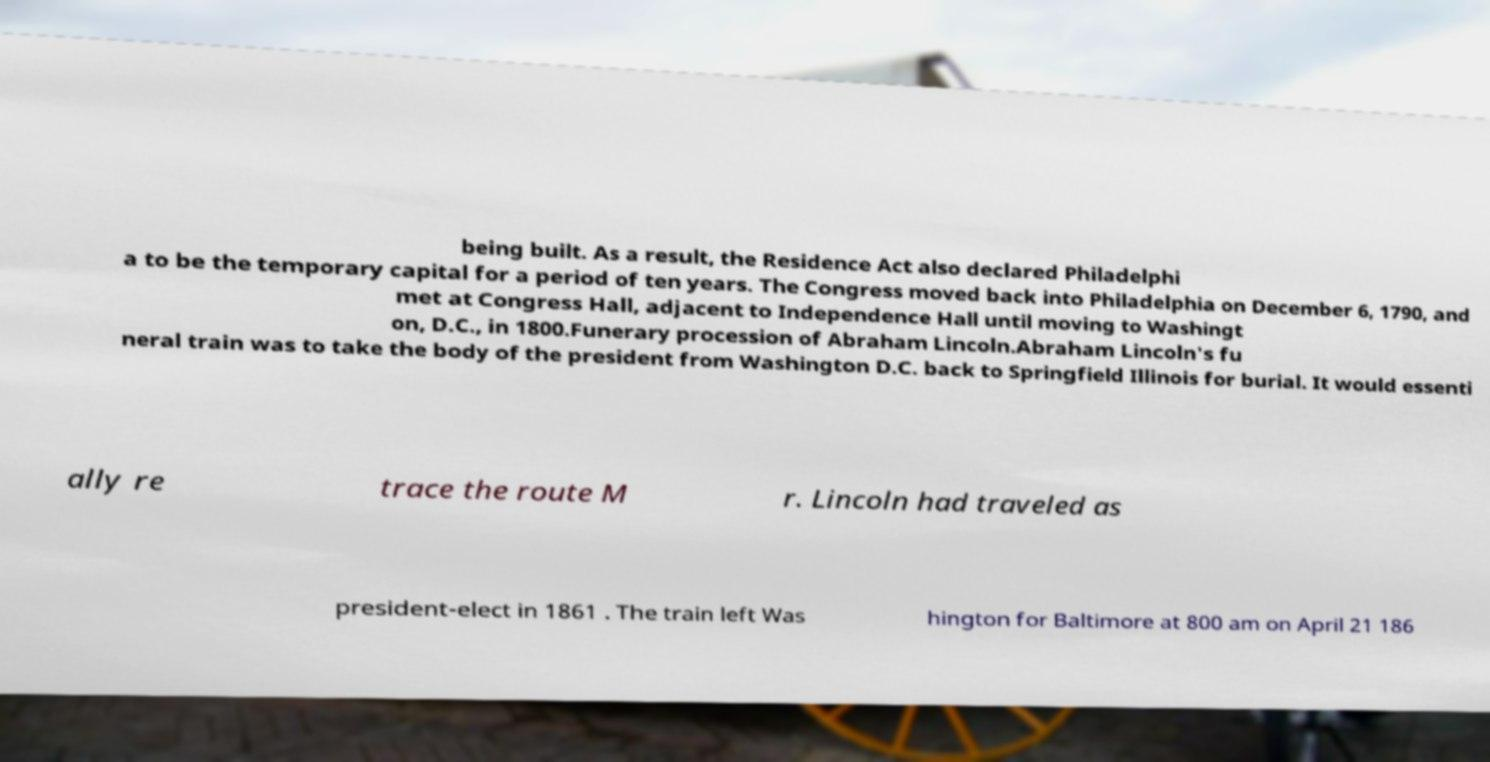Can you read and provide the text displayed in the image?This photo seems to have some interesting text. Can you extract and type it out for me? being built. As a result, the Residence Act also declared Philadelphi a to be the temporary capital for a period of ten years. The Congress moved back into Philadelphia on December 6, 1790, and met at Congress Hall, adjacent to Independence Hall until moving to Washingt on, D.C., in 1800.Funerary procession of Abraham Lincoln.Abraham Lincoln's fu neral train was to take the body of the president from Washington D.C. back to Springfield Illinois for burial. It would essenti ally re trace the route M r. Lincoln had traveled as president-elect in 1861 . The train left Was hington for Baltimore at 800 am on April 21 186 